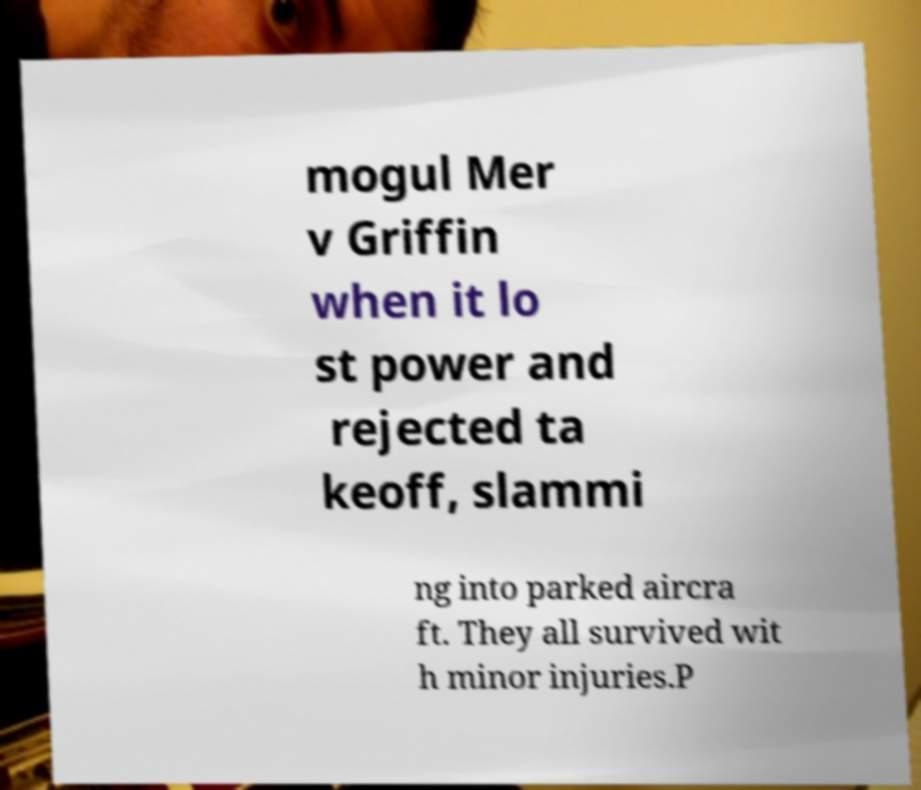For documentation purposes, I need the text within this image transcribed. Could you provide that? mogul Mer v Griffin when it lo st power and rejected ta keoff, slammi ng into parked aircra ft. They all survived wit h minor injuries.P 